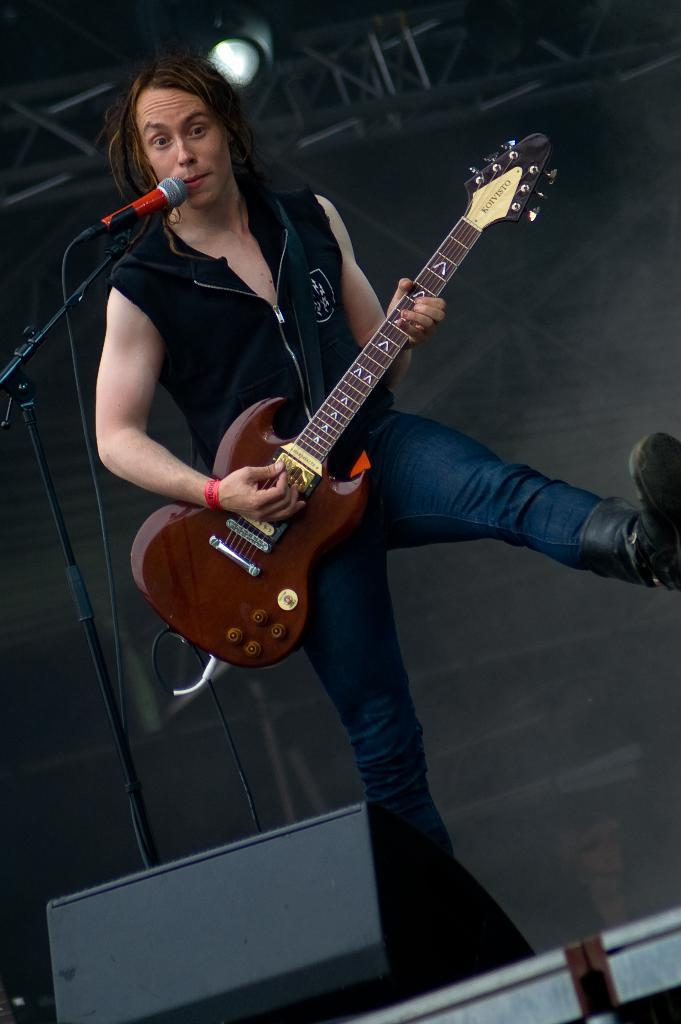What is the person in the image doing? The person is playing the guitar. What is the person wearing in the image? The person is wearing a black shirt and blue jeans. What object is the person holding in the image? The person is holding a guitar. What objects are in front of the person in the image? There is a microphone and a speaker in front of the person. How many frogs are sitting on the branch in the image? There are no frogs or branches present in the image. What type of substance is being used by the person in the image? There is no substance being used by the person in the image; they are simply playing the guitar. 